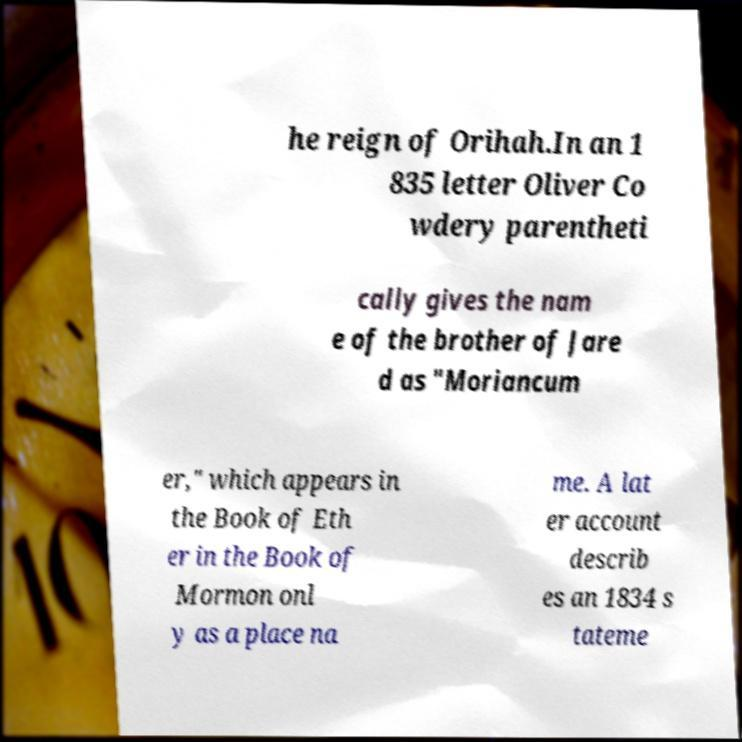What messages or text are displayed in this image? I need them in a readable, typed format. he reign of Orihah.In an 1 835 letter Oliver Co wdery parentheti cally gives the nam e of the brother of Jare d as "Moriancum er," which appears in the Book of Eth er in the Book of Mormon onl y as a place na me. A lat er account describ es an 1834 s tateme 